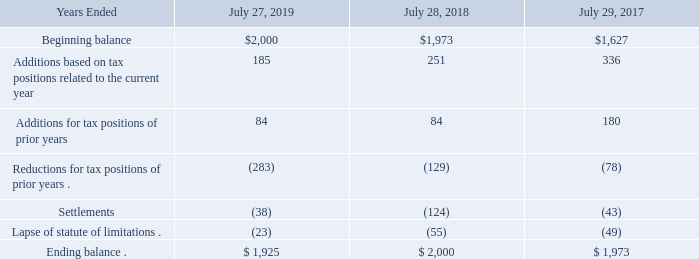Unrecognized Tax Benefits
The aggregate changes in the balance of gross unrecognized tax benefits were as follows (in millions):
As of July 27, 2019, $1.7 billion of the unrecognized tax benefits would affect the effective tax rate if realized. During fiscal 2019, we recognized $30 million of net interest expense and $6 million of penalty expense. During fiscal 2018, we recognized $10 million of net interest expense and no net penalty expense. During fiscal 2017, we recognized $26 million of net interest expense and a $4 million reduction in penalties. Our total accrual for interest and penalties was $220 million, $180 million, and $186 million as of the end of fiscal 2019, 2018, and 2017, respectively. We are no longer subject to U.S. federal income tax audit for returns covering tax years through fiscal 2010. We are no longer subject to foreign or state income tax audits for returns covering tax years through fiscal 1999 and fiscal 2008, respectively.
We regularly engage in discussions and negotiations with tax authorities regarding tax matters in various jurisdictions. We believe it is reasonably possible that certain federal, foreign, and state tax matters may be concluded in the next 12 months. Specific positions that may be resolved include issues involving transfer pricing and various other matters. We estimate that the unrecognized tax benefits at July 27, 2019 could be reduced by $50 million in the next 12 months.
How much net interest expense did the company recognize in fiscal year 2019? $30 million. What was the company's total accrual for interest and penalties in fiscal 2018? $180 million. What were the Additions for tax positions of prior years in 2019?
Answer scale should be: million. 84. What was the change in the Additions based on tax positions related to the current year between 2017 and 2018?
Answer scale should be: million. 251-336
Answer: -85. How many years did Additions for tax positions of prior years exceed $100 million?
Answer scale should be: million. 2017
Answer: 1. What was the percentage change in the Beginning balance between 2018 and 2019?
Answer scale should be: percent. (2,000-1,973)/1,973
Answer: 1.37. 